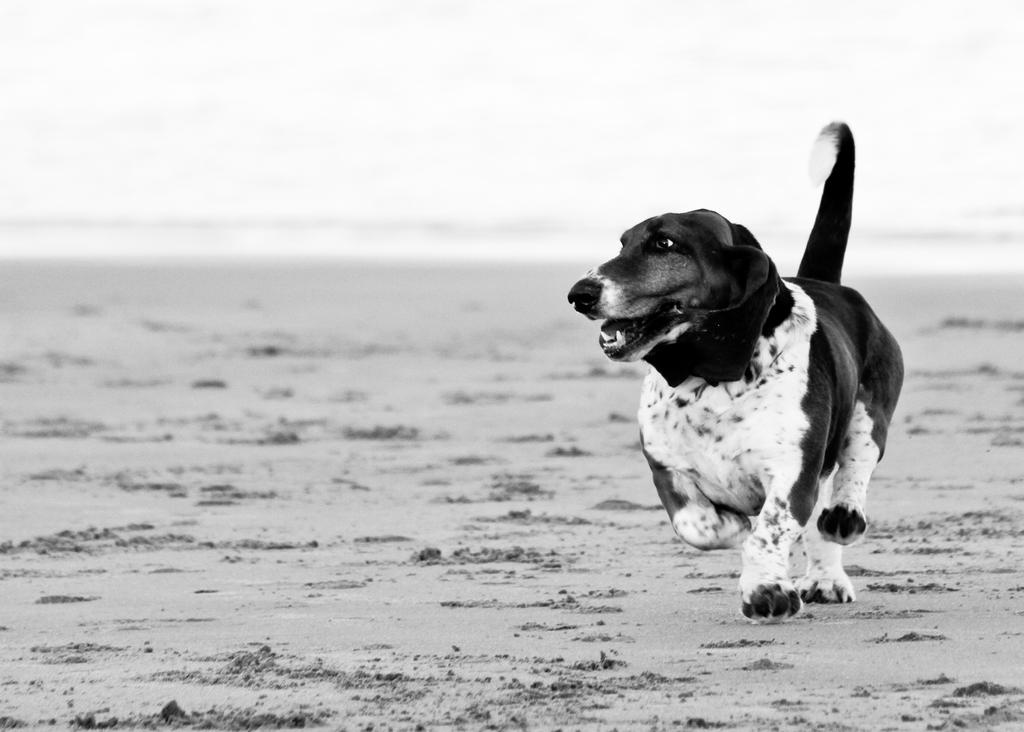What is the color scheme of the image? The image is black and white. What animal can be seen in the image? There is a dog in the image. What is the dog doing in the image? The dog is running. What type of surface is the dog running on? The dog is running on sand. What type of wine is the dog drinking in the image? There is no wine present in the image; it features a dog running on sand. 